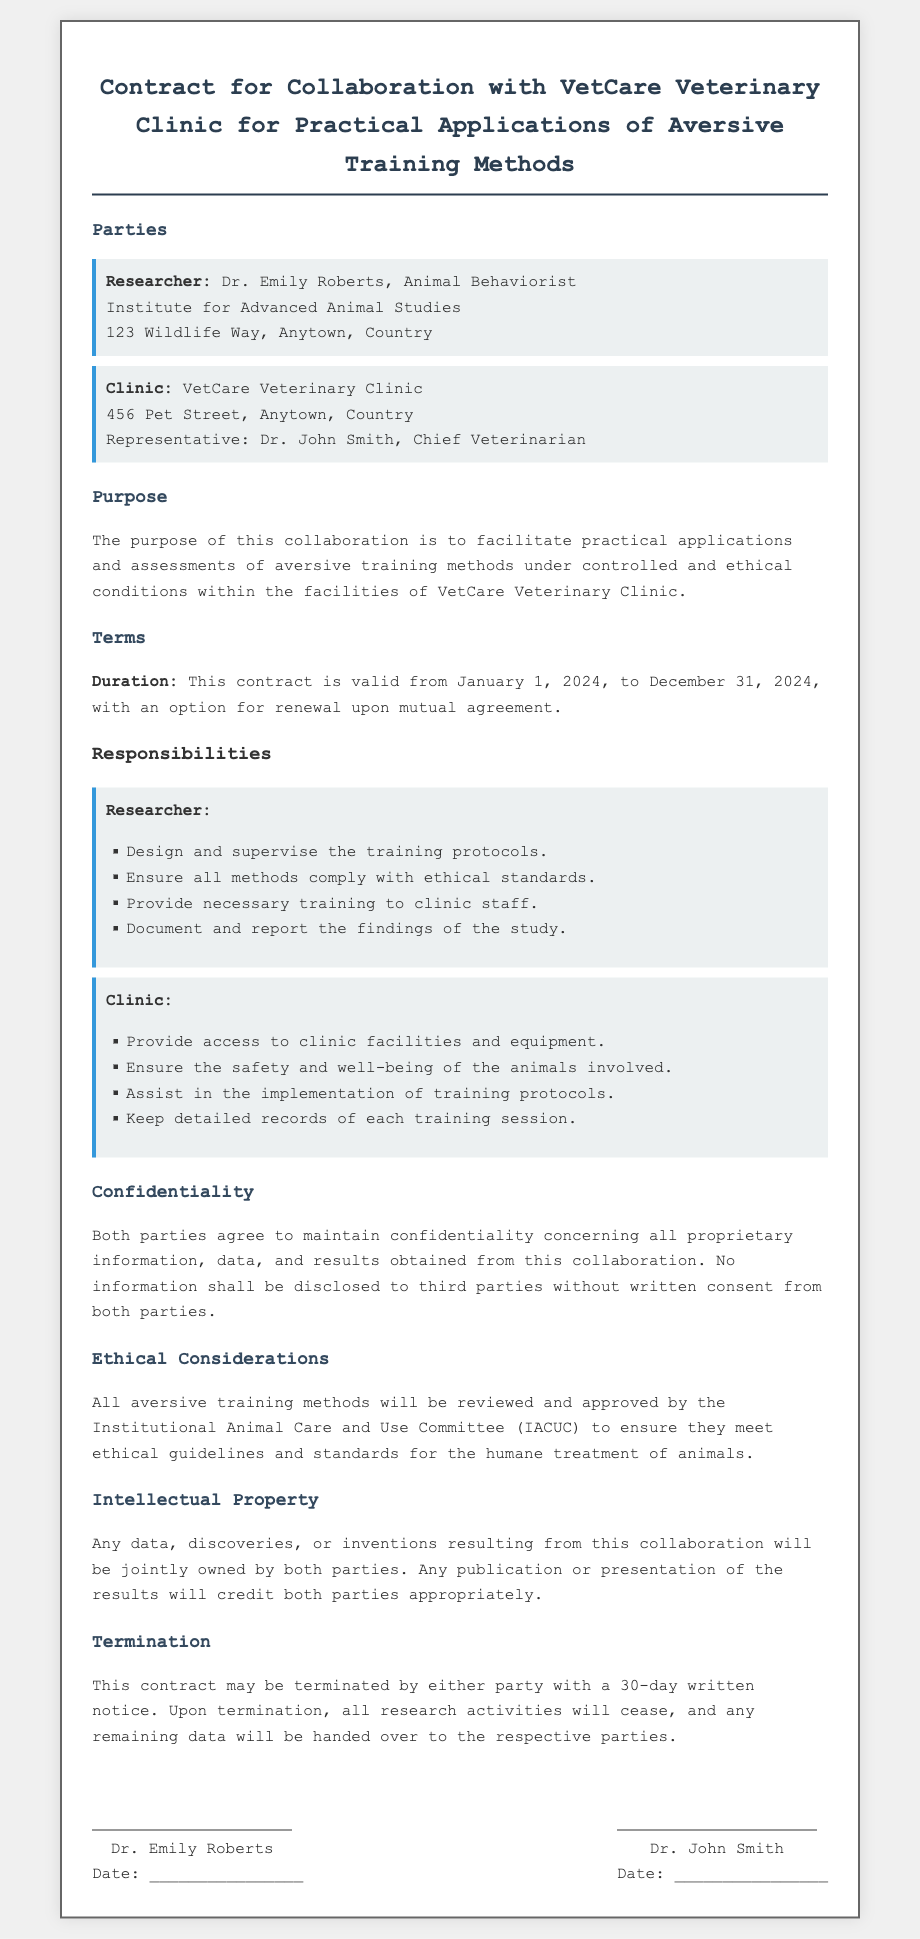What is the name of the researcher? The researcher is identified as Dr. Emily Roberts in the document.
Answer: Dr. Emily Roberts What is the duration of the contract? The duration is specified in the document as from January 1, 2024, to December 31, 2024.
Answer: January 1, 2024, to December 31, 2024 Who represents the veterinary clinic? The document mentions that Dr. John Smith is the representative of the clinic.
Answer: Dr. John Smith What committee must approve the aversive training methods? The document notes that the Institutional Animal Care and Use Committee (IACUC) must approve the methods.
Answer: Institutional Animal Care and Use Committee (IACUC) How many days' notice is required for termination of the contract? The required notice period for termination is stated as 30 days in the document.
Answer: 30 days What will happen to the data upon termination of the contract? The document states that remaining data will be handed over to the respective parties upon termination.
Answer: Handed over to the respective parties What should be documented according to the clinic's responsibilities? The clinic is required to keep detailed records of each training session according to the terms.
Answer: Detailed records of each training session What is the purpose of the collaboration? The document specifies that the purpose is to facilitate practical applications and assessments of aversive training methods.
Answer: To facilitate practical applications and assessments of aversive training methods 